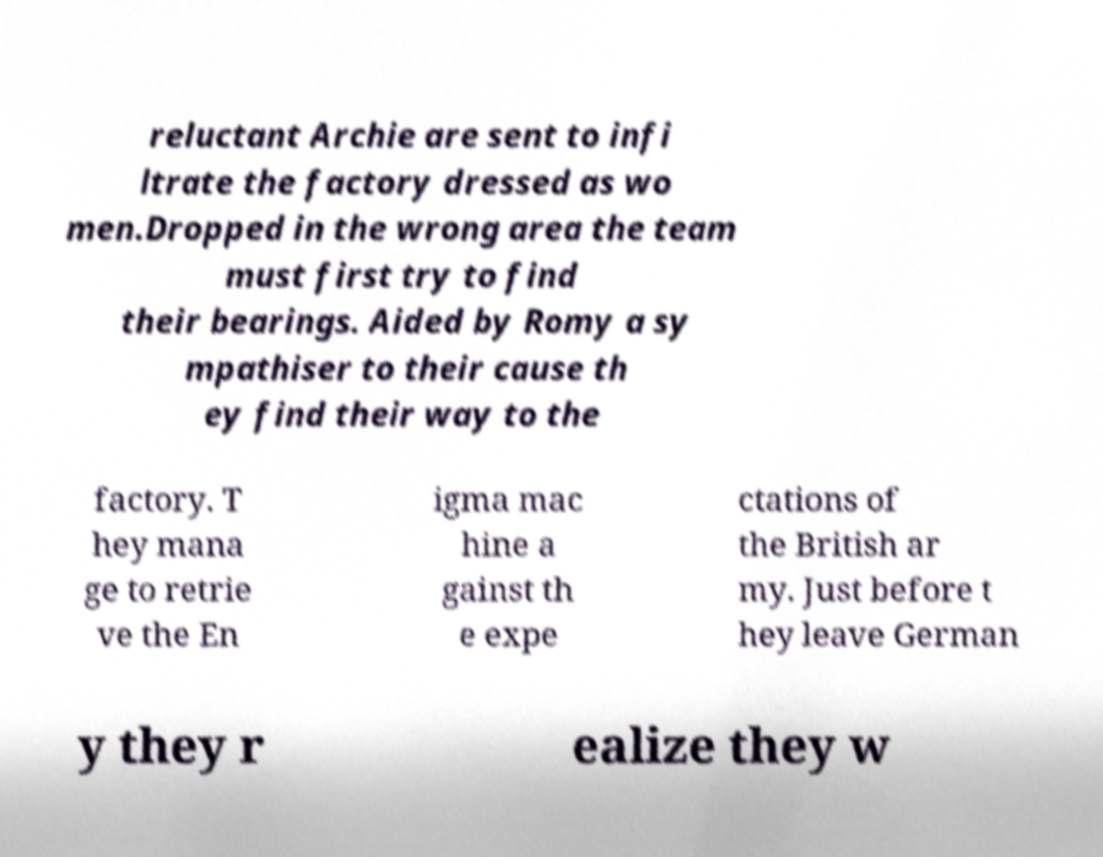Could you assist in decoding the text presented in this image and type it out clearly? reluctant Archie are sent to infi ltrate the factory dressed as wo men.Dropped in the wrong area the team must first try to find their bearings. Aided by Romy a sy mpathiser to their cause th ey find their way to the factory. T hey mana ge to retrie ve the En igma mac hine a gainst th e expe ctations of the British ar my. Just before t hey leave German y they r ealize they w 